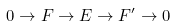Convert formula to latex. <formula><loc_0><loc_0><loc_500><loc_500>0 \to F \to E \to F ^ { \prime } \to 0</formula> 